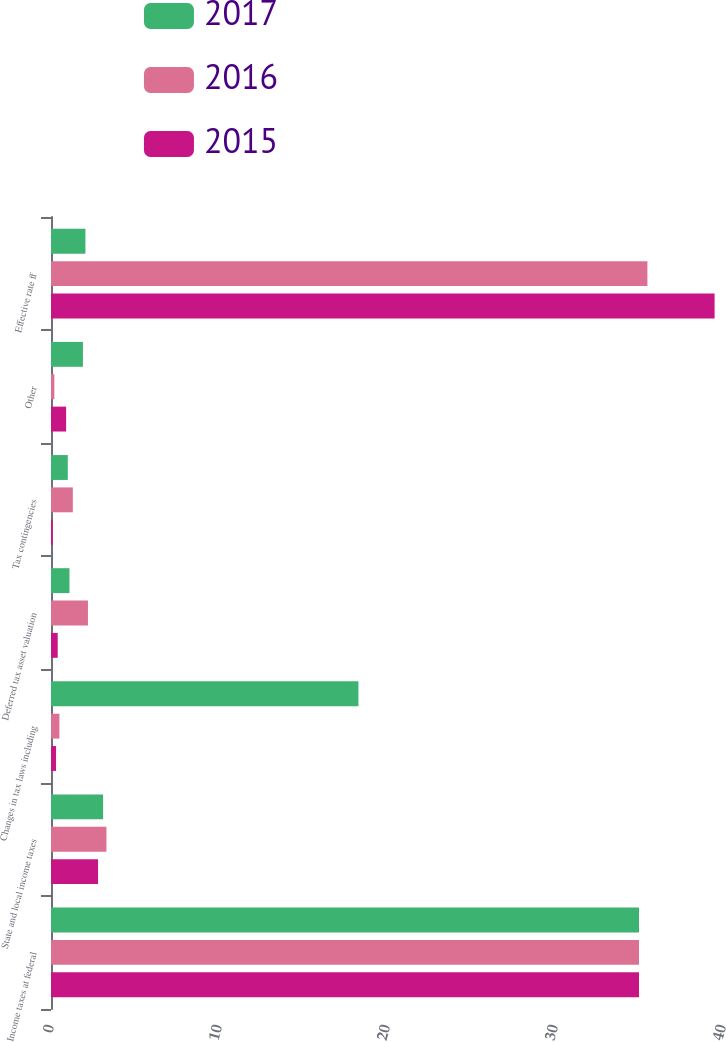<chart> <loc_0><loc_0><loc_500><loc_500><stacked_bar_chart><ecel><fcel>Income taxes at federal<fcel>State and local income taxes<fcel>Changes in tax laws including<fcel>Deferred tax asset valuation<fcel>Tax contingencies<fcel>Other<fcel>Effective rate ff<nl><fcel>2017<fcel>35<fcel>3.1<fcel>18.3<fcel>1.1<fcel>1<fcel>1.9<fcel>2.05<nl><fcel>2016<fcel>35<fcel>3.3<fcel>0.5<fcel>2.2<fcel>1.3<fcel>0.2<fcel>35.5<nl><fcel>2015<fcel>35<fcel>2.8<fcel>0.3<fcel>0.4<fcel>0.1<fcel>0.9<fcel>39.5<nl></chart> 